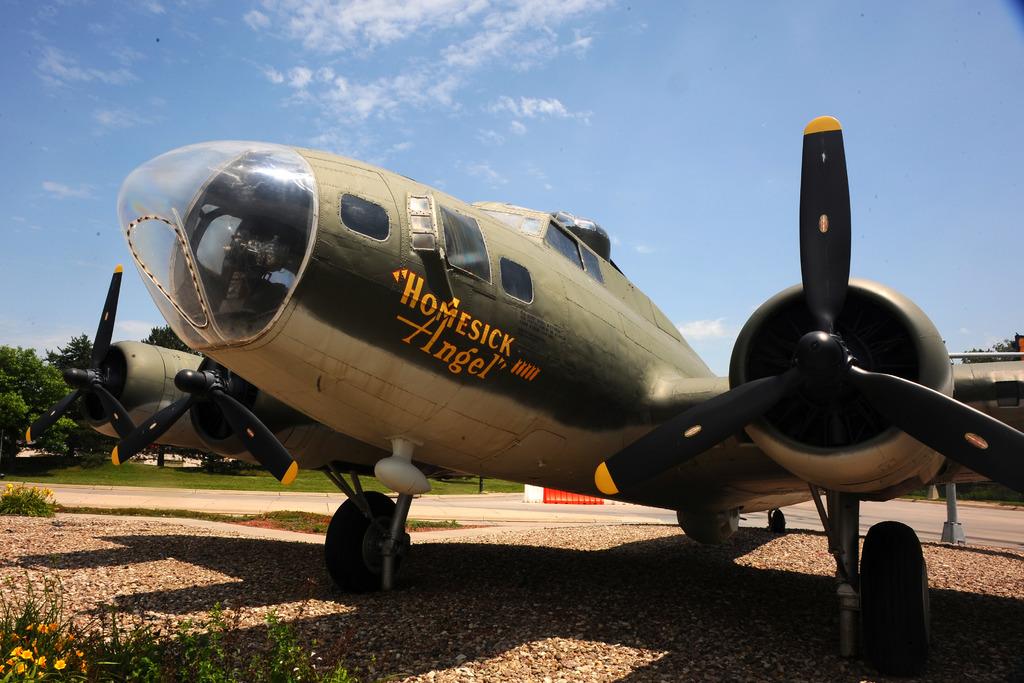What's this plane's nickname?
Offer a terse response. Homesick angel. 